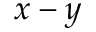<formula> <loc_0><loc_0><loc_500><loc_500>x - y</formula> 